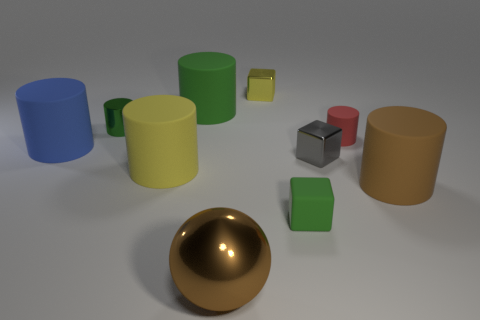Subtract all red cylinders. How many cylinders are left? 5 Subtract 2 cylinders. How many cylinders are left? 4 Subtract all large green rubber cylinders. How many cylinders are left? 5 Subtract all cyan cylinders. Subtract all gray cubes. How many cylinders are left? 6 Subtract all spheres. How many objects are left? 9 Add 9 brown metallic spheres. How many brown metallic spheres are left? 10 Add 1 blue rubber cylinders. How many blue rubber cylinders exist? 2 Subtract 0 cyan cylinders. How many objects are left? 10 Subtract all small green spheres. Subtract all gray metallic objects. How many objects are left? 9 